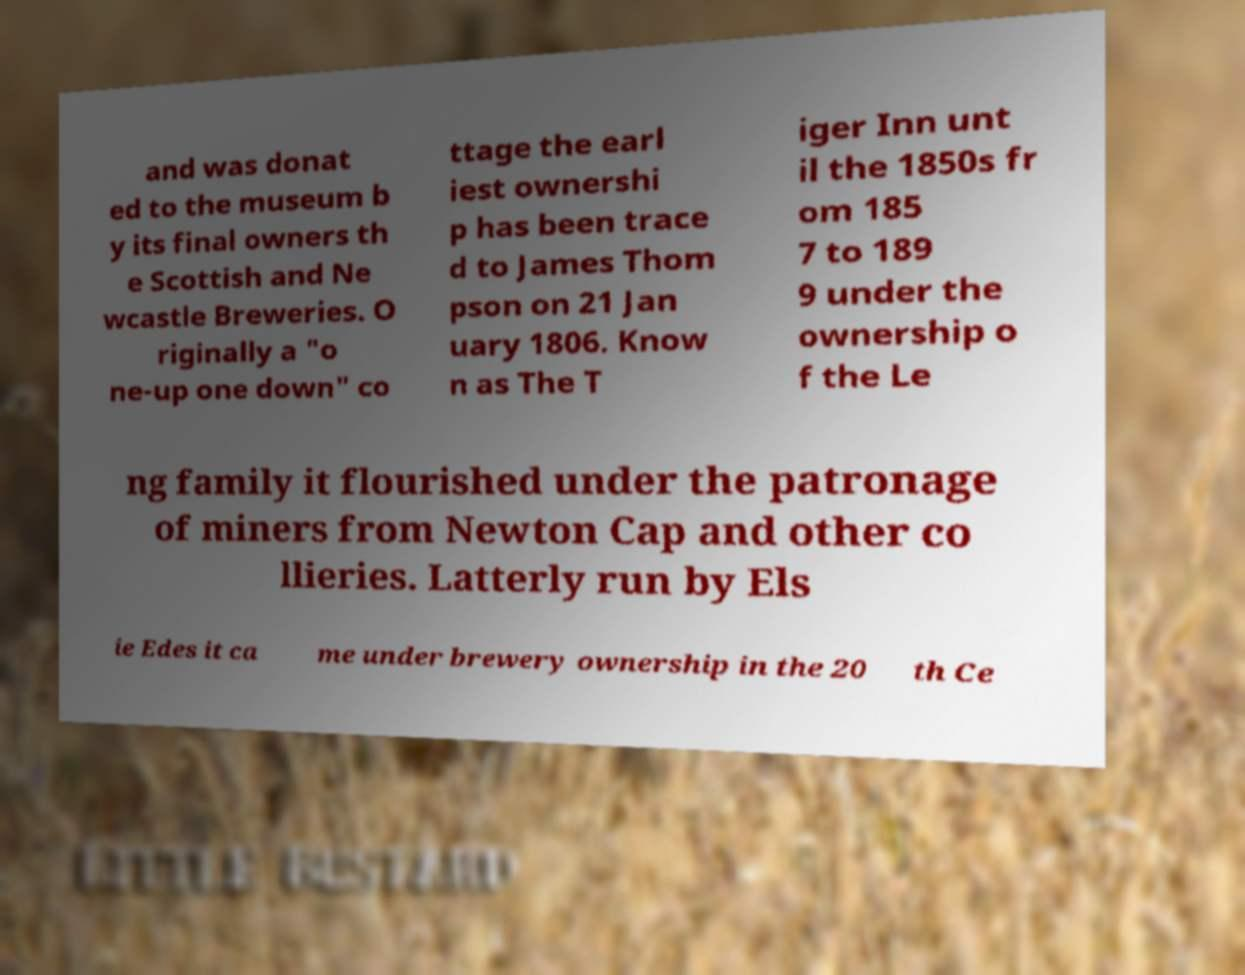Could you extract and type out the text from this image? and was donat ed to the museum b y its final owners th e Scottish and Ne wcastle Breweries. O riginally a "o ne-up one down" co ttage the earl iest ownershi p has been trace d to James Thom pson on 21 Jan uary 1806. Know n as The T iger Inn unt il the 1850s fr om 185 7 to 189 9 under the ownership o f the Le ng family it flourished under the patronage of miners from Newton Cap and other co llieries. Latterly run by Els ie Edes it ca me under brewery ownership in the 20 th Ce 